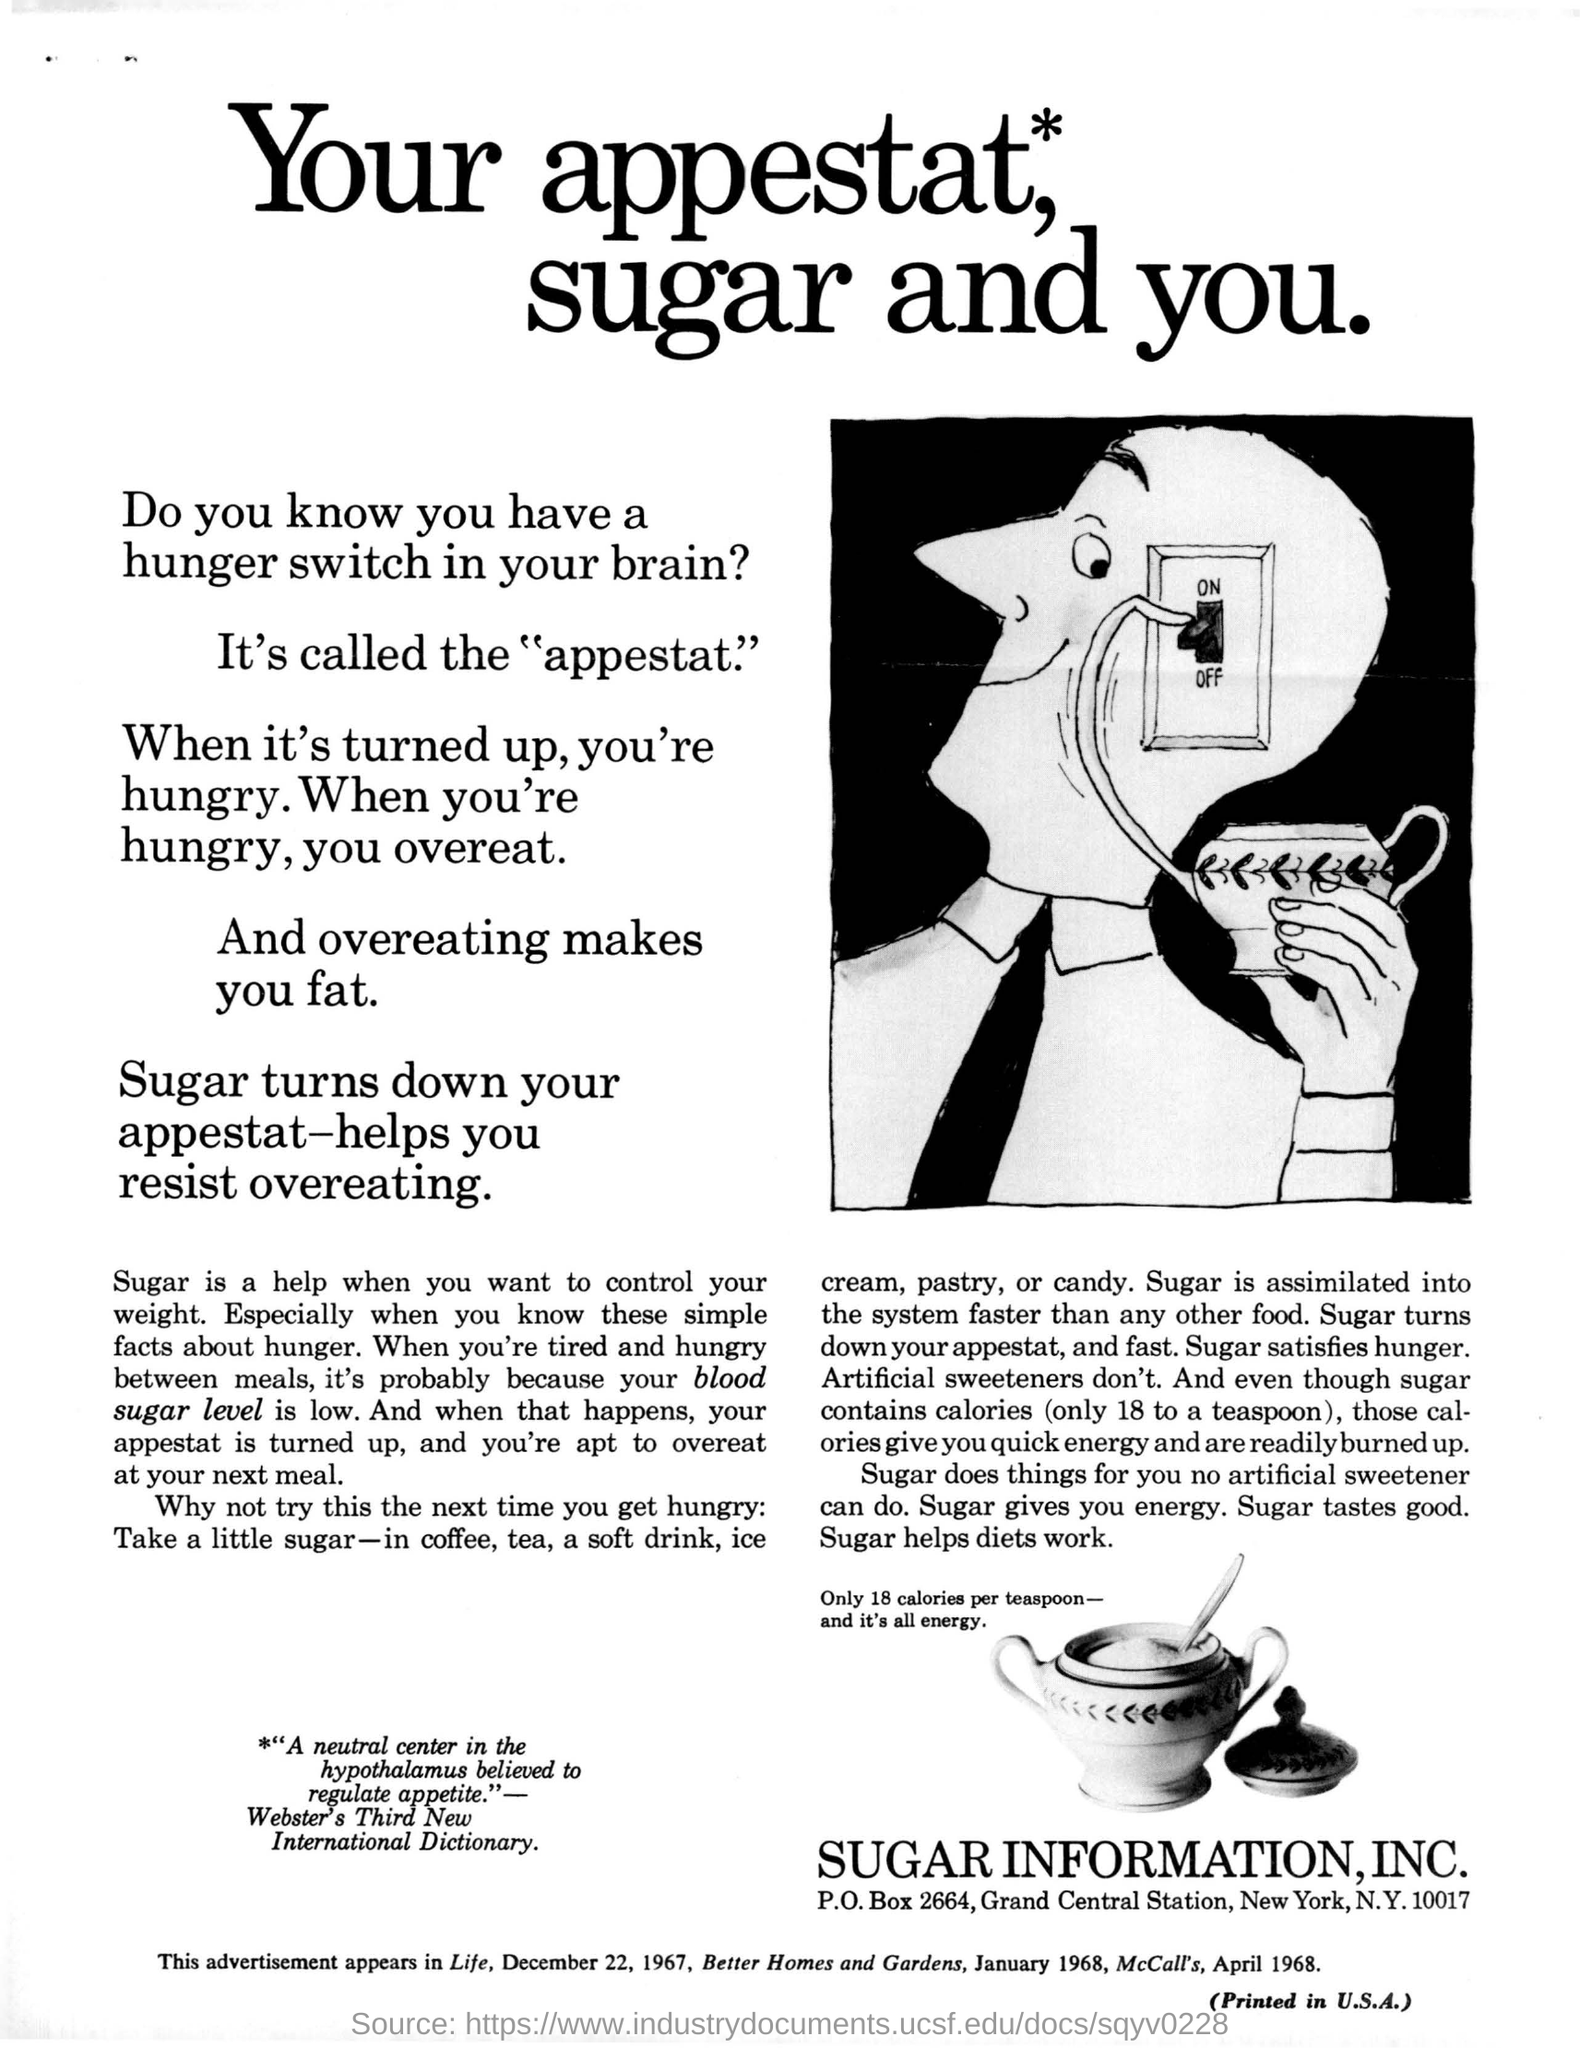Mention a couple of crucial points in this snapshot. The hunger switch in the brain, which is known as the appestat, regulates one's appetite. A teaspoon of sugar contains approximately 18 calories. The address for Sugar Information, Inc. is P.O. Box 2664, Grand Central Station, New York, New York 10017. 